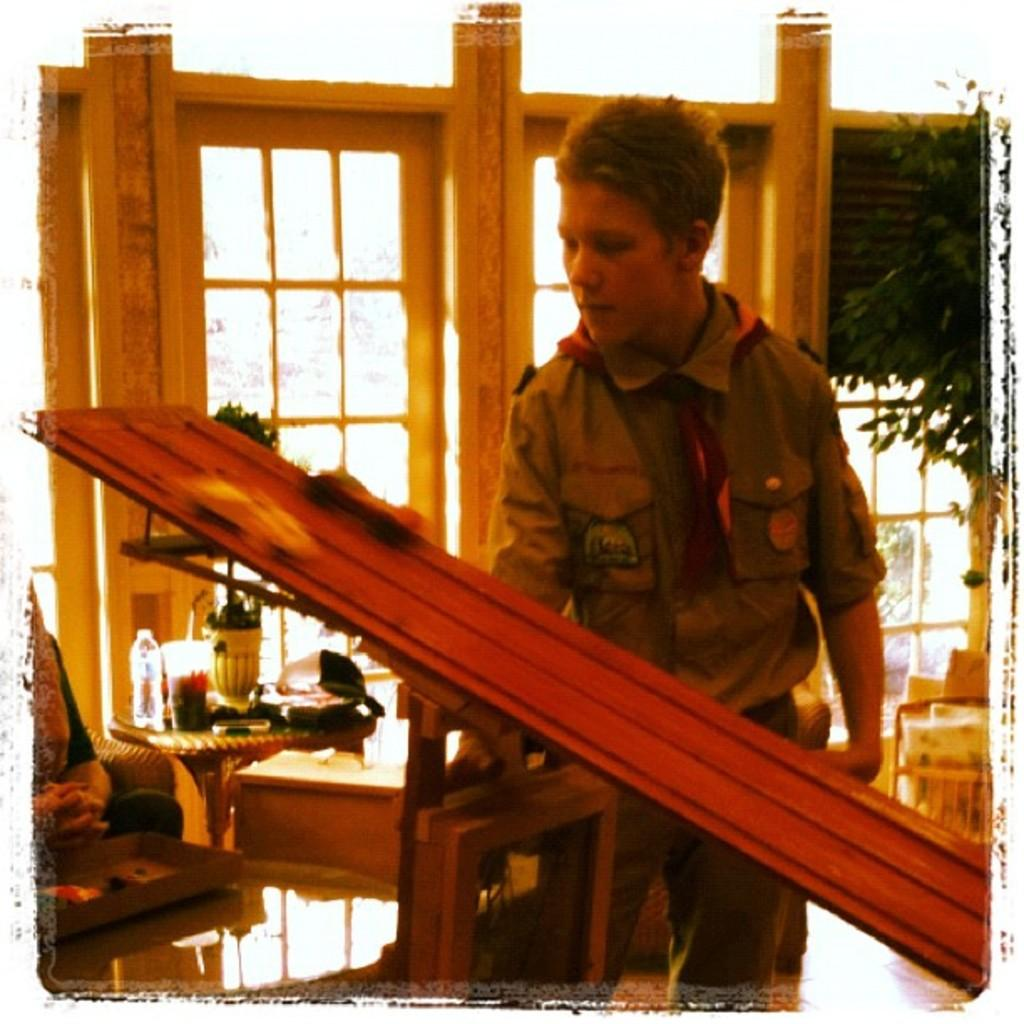Who or what is present in the image? There is a person in the image. What is the person wearing? The person is wearing a brown shirt. What is the person holding in the image? The person is holding an object. What can be seen in the right corner of the image? There is a tree in the right corner of the image. What type of meat is being cooked in the image? There is no meat or cooking activity present in the image. 